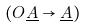Convert formula to latex. <formula><loc_0><loc_0><loc_500><loc_500>( O \underline { A } \rightarrow \underline { A } )</formula> 